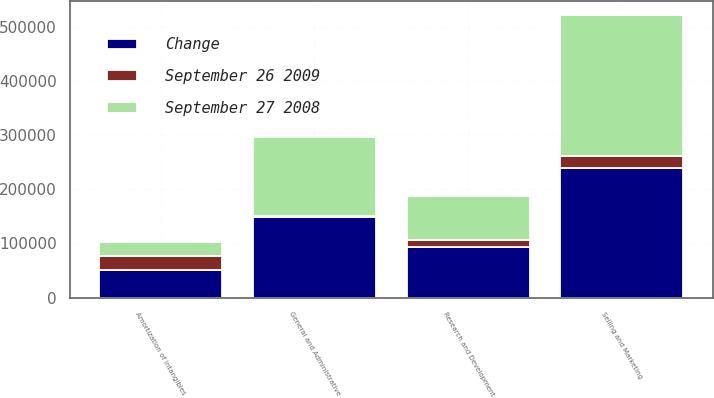Convert chart to OTSL. <chart><loc_0><loc_0><loc_500><loc_500><stacked_bar_chart><ecel><fcel>Research and Development<fcel>Selling and Marketing<fcel>General and Administrative<fcel>Amortization of Intangibles<nl><fcel>Change<fcel>94328<fcel>238977<fcel>148824<fcel>51210<nl><fcel>September 27 2008<fcel>81421<fcel>261524<fcel>147405<fcel>25227<nl><fcel>September 26 2009<fcel>12907<fcel>22547<fcel>1419<fcel>25983<nl></chart> 